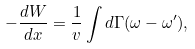Convert formula to latex. <formula><loc_0><loc_0><loc_500><loc_500>- \frac { d W } { d x } = \frac { 1 } { v } \int d \Gamma ( \omega - \omega ^ { \prime } ) ,</formula> 